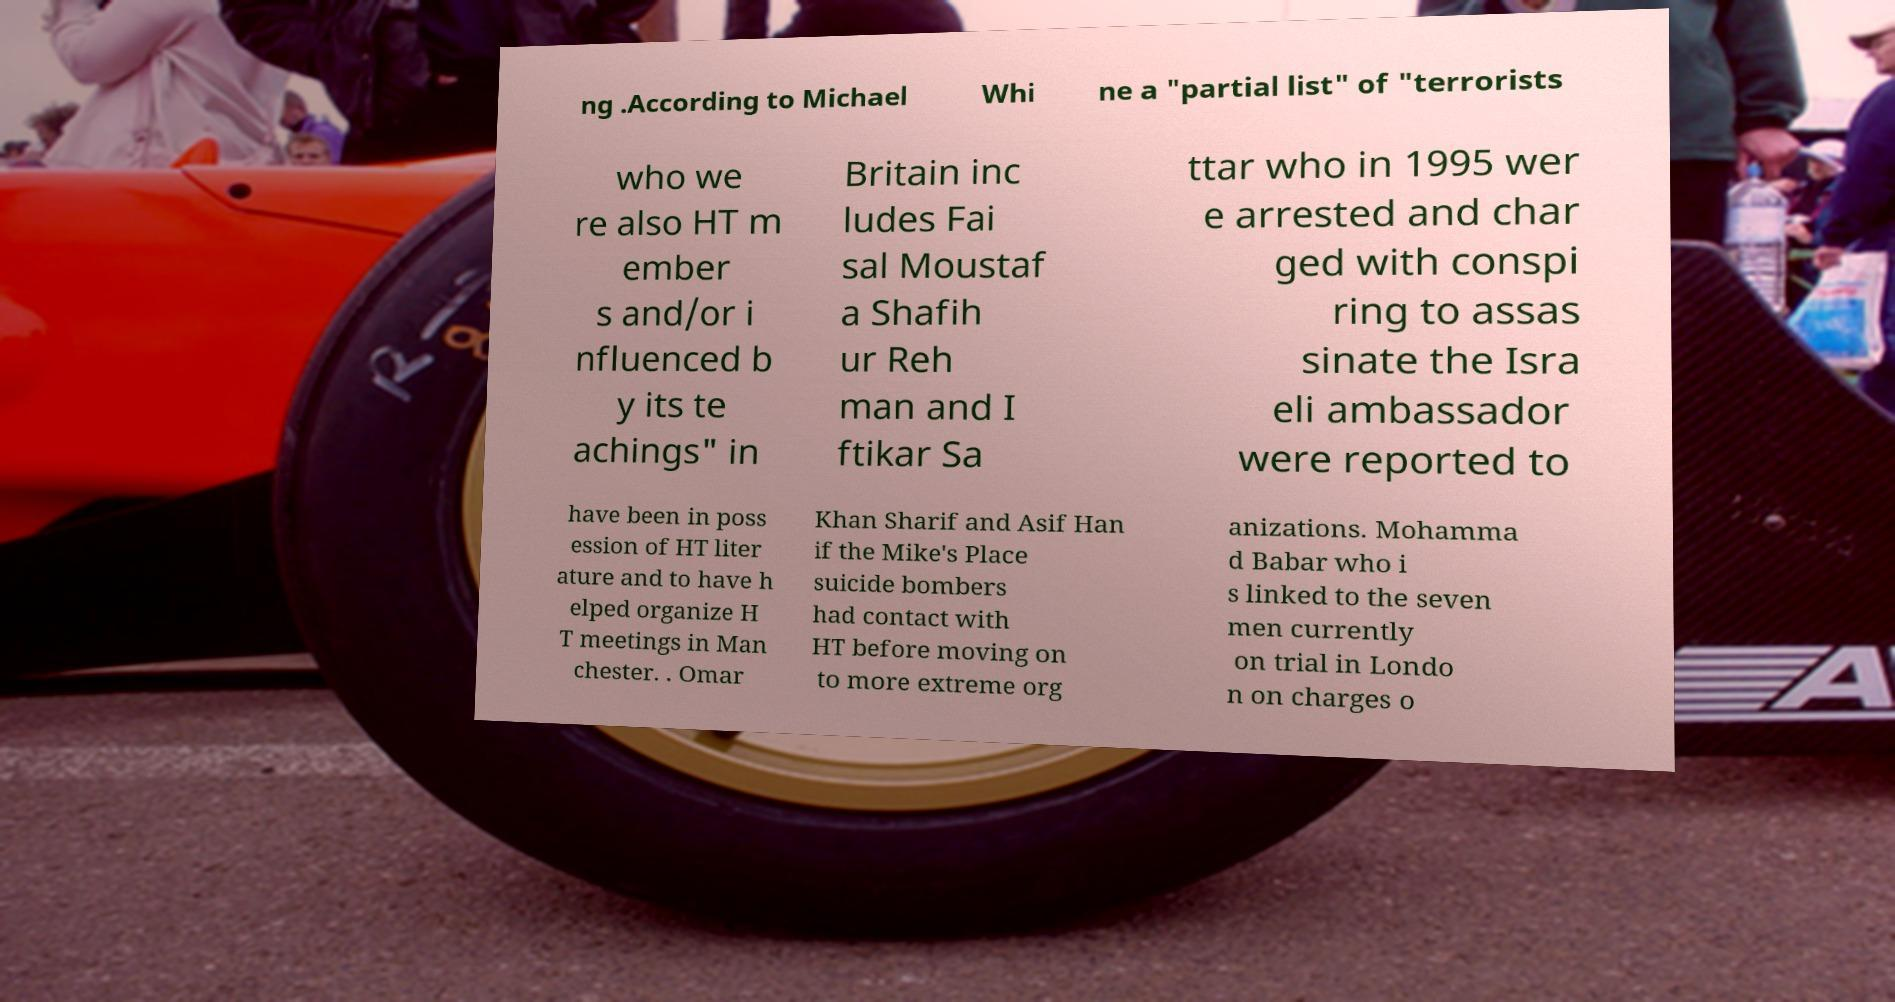I need the written content from this picture converted into text. Can you do that? ng .According to Michael Whi ne a "partial list" of "terrorists who we re also HT m ember s and/or i nfluenced b y its te achings" in Britain inc ludes Fai sal Moustaf a Shafih ur Reh man and I ftikar Sa ttar who in 1995 wer e arrested and char ged with conspi ring to assas sinate the Isra eli ambassador were reported to have been in poss ession of HT liter ature and to have h elped organize H T meetings in Man chester. . Omar Khan Sharif and Asif Han if the Mike's Place suicide bombers had contact with HT before moving on to more extreme org anizations. Mohamma d Babar who i s linked to the seven men currently on trial in Londo n on charges o 